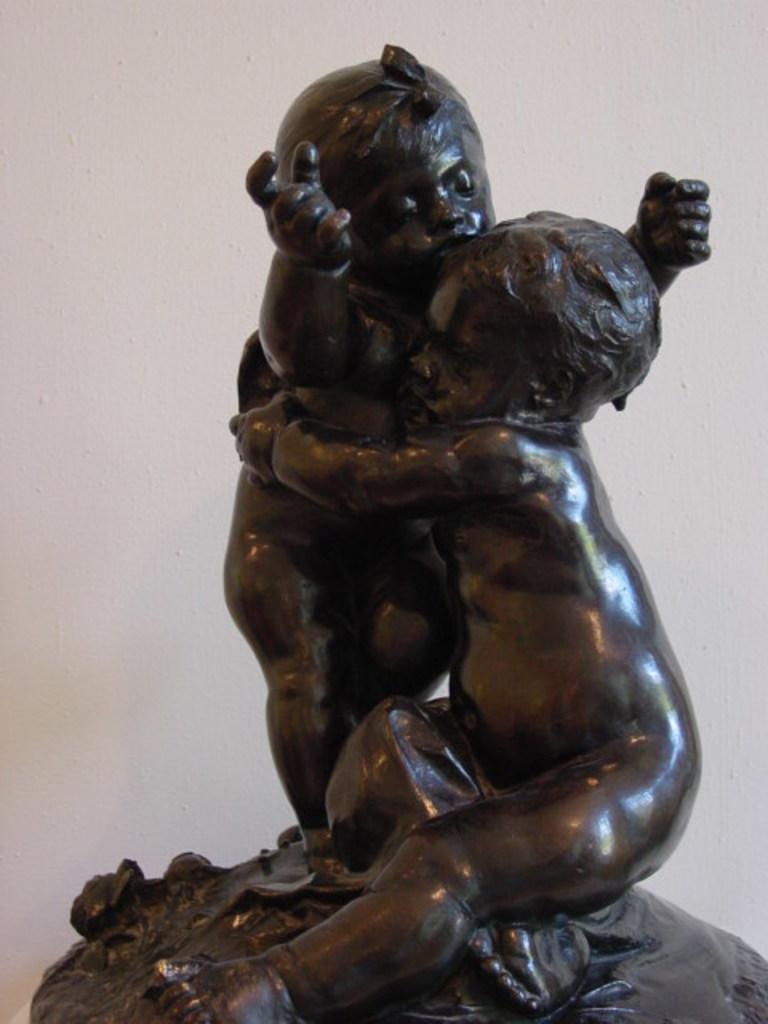What is the main subject of the image? There is a sculpture of two babies in the image. Can you describe the background of the image? There is a wall in the background of the image. What type of shirt is the baby wearing in the image? The sculpture is of two babies, not living babies, so they are not wearing any clothing. 